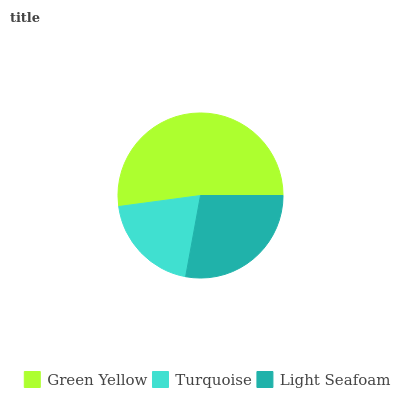Is Turquoise the minimum?
Answer yes or no. Yes. Is Green Yellow the maximum?
Answer yes or no. Yes. Is Light Seafoam the minimum?
Answer yes or no. No. Is Light Seafoam the maximum?
Answer yes or no. No. Is Light Seafoam greater than Turquoise?
Answer yes or no. Yes. Is Turquoise less than Light Seafoam?
Answer yes or no. Yes. Is Turquoise greater than Light Seafoam?
Answer yes or no. No. Is Light Seafoam less than Turquoise?
Answer yes or no. No. Is Light Seafoam the high median?
Answer yes or no. Yes. Is Light Seafoam the low median?
Answer yes or no. Yes. Is Turquoise the high median?
Answer yes or no. No. Is Green Yellow the low median?
Answer yes or no. No. 